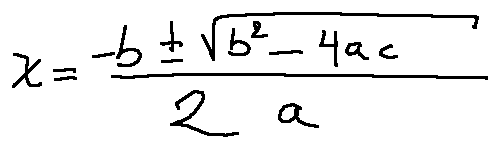Convert formula to latex. <formula><loc_0><loc_0><loc_500><loc_500>x = \frac { - b \pm \sqrt { b ^ { 2 } - 4 a c } } { 2 a }</formula> 